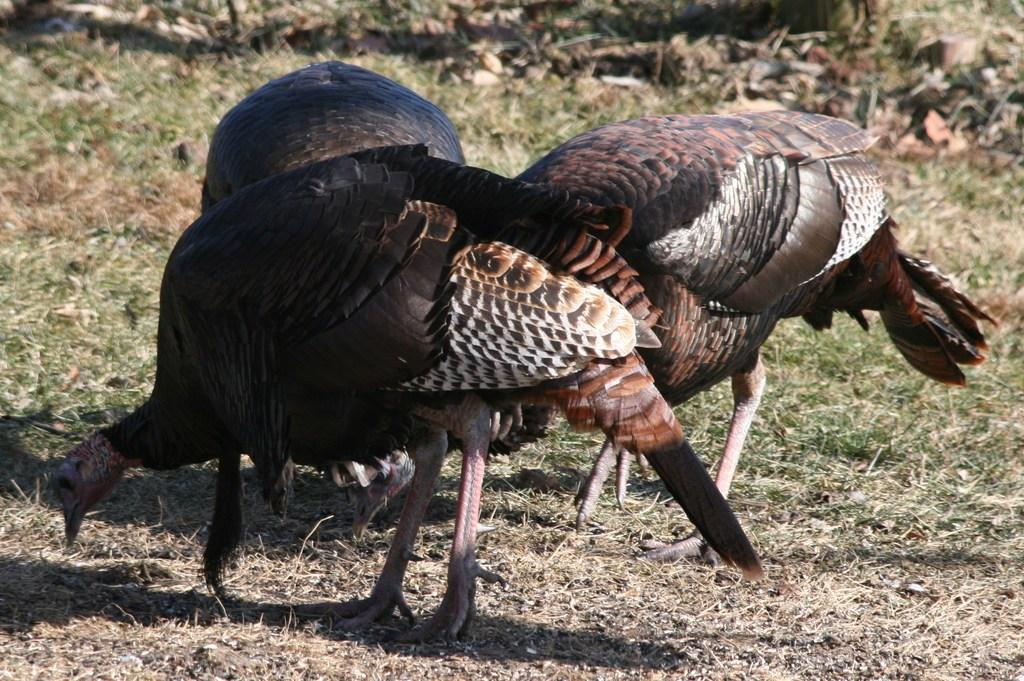What type of animals are in the picture? There are turkeys in the picture. What type of vegetation is present in the image? The picture contains grass. What type of form or receipt can be seen in the picture? There is no form or receipt present in the picture; it features turkeys and grass. Is there a cemetery visible in the picture? There is no cemetery present in the picture; it features turkeys and grass. 